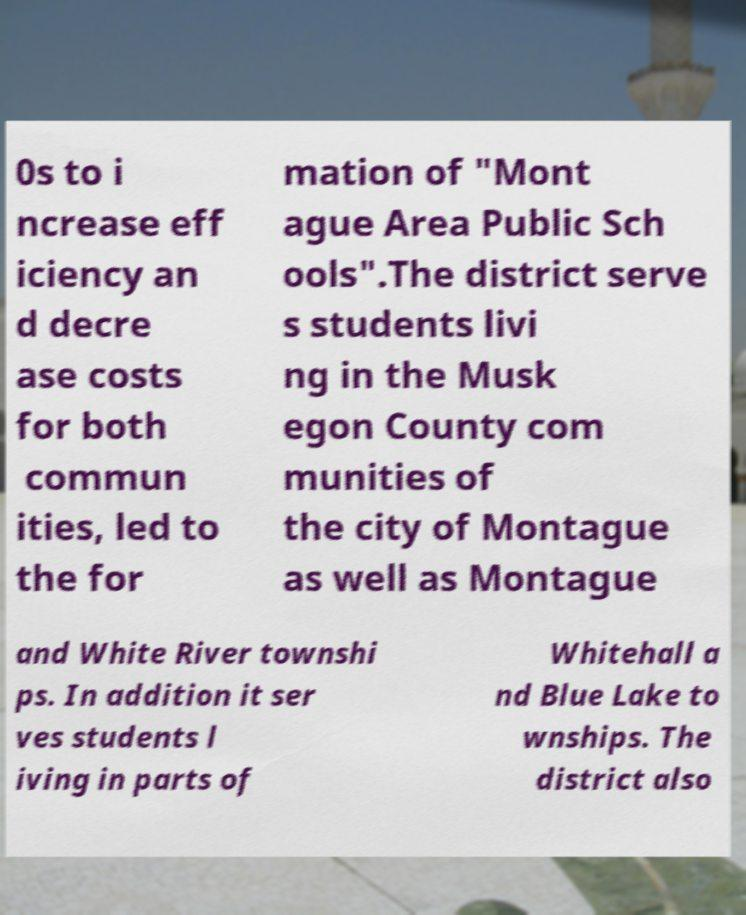Can you read and provide the text displayed in the image?This photo seems to have some interesting text. Can you extract and type it out for me? 0s to i ncrease eff iciency an d decre ase costs for both commun ities, led to the for mation of "Mont ague Area Public Sch ools".The district serve s students livi ng in the Musk egon County com munities of the city of Montague as well as Montague and White River townshi ps. In addition it ser ves students l iving in parts of Whitehall a nd Blue Lake to wnships. The district also 